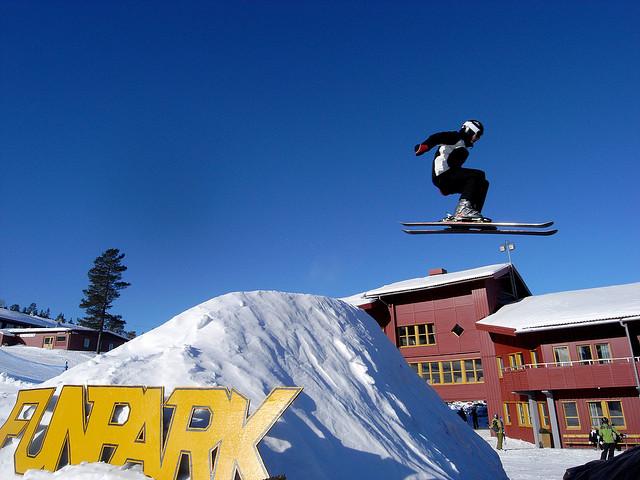Is the guy going to jump over the houses?
Quick response, please. No. Is this guy jumping over the?
Be succinct. Yes. What sport is this?
Quick response, please. Skiing. Is this person snowboarding?
Be succinct. No. 